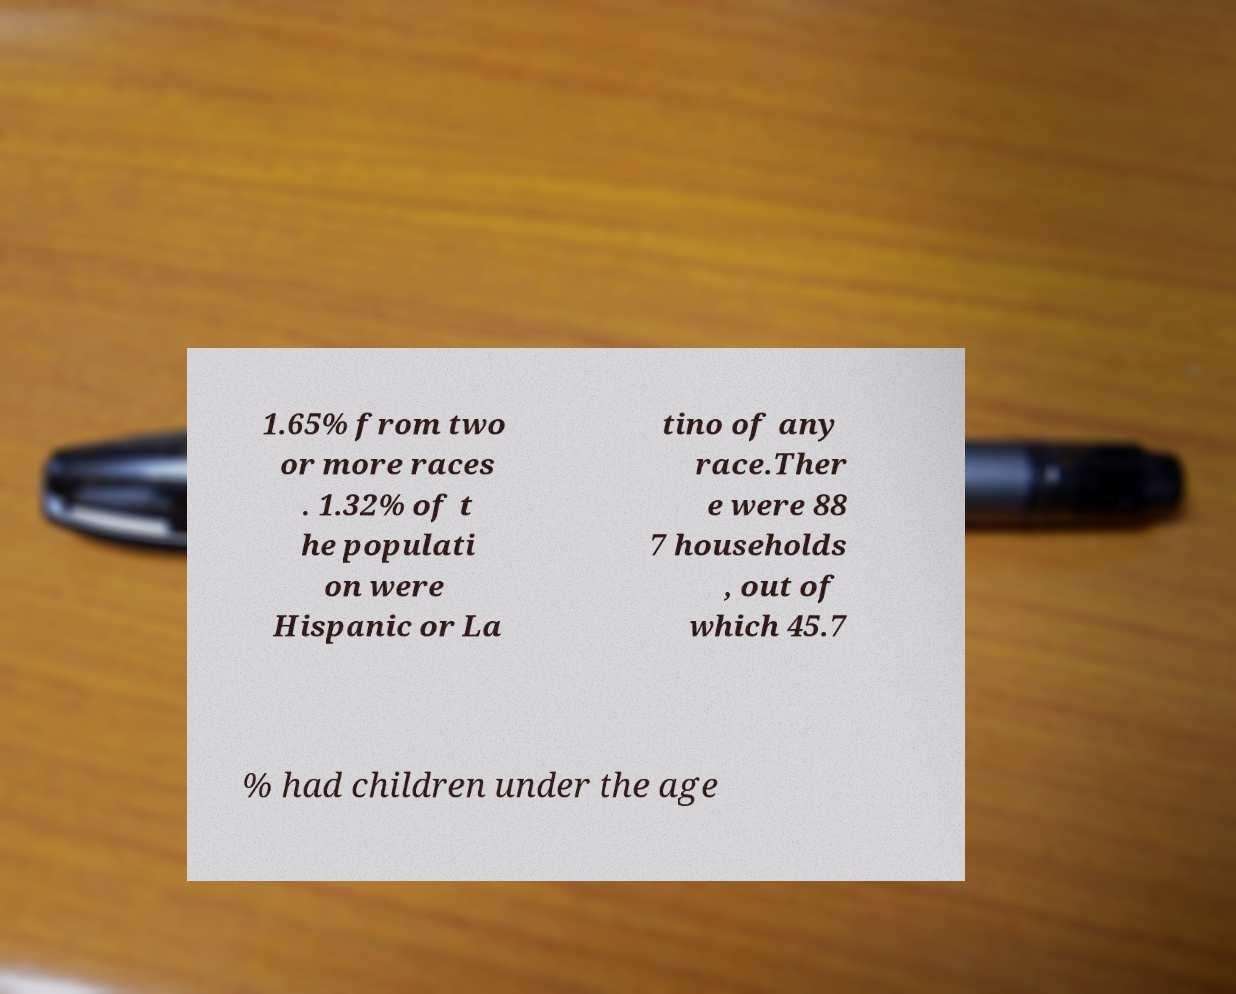Please identify and transcribe the text found in this image. 1.65% from two or more races . 1.32% of t he populati on were Hispanic or La tino of any race.Ther e were 88 7 households , out of which 45.7 % had children under the age 